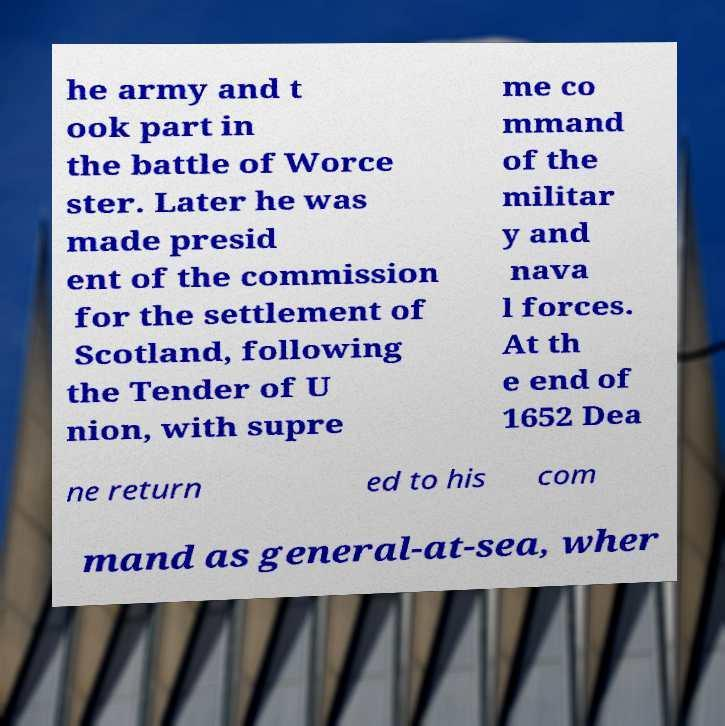Could you extract and type out the text from this image? he army and t ook part in the battle of Worce ster. Later he was made presid ent of the commission for the settlement of Scotland, following the Tender of U nion, with supre me co mmand of the militar y and nava l forces. At th e end of 1652 Dea ne return ed to his com mand as general-at-sea, wher 